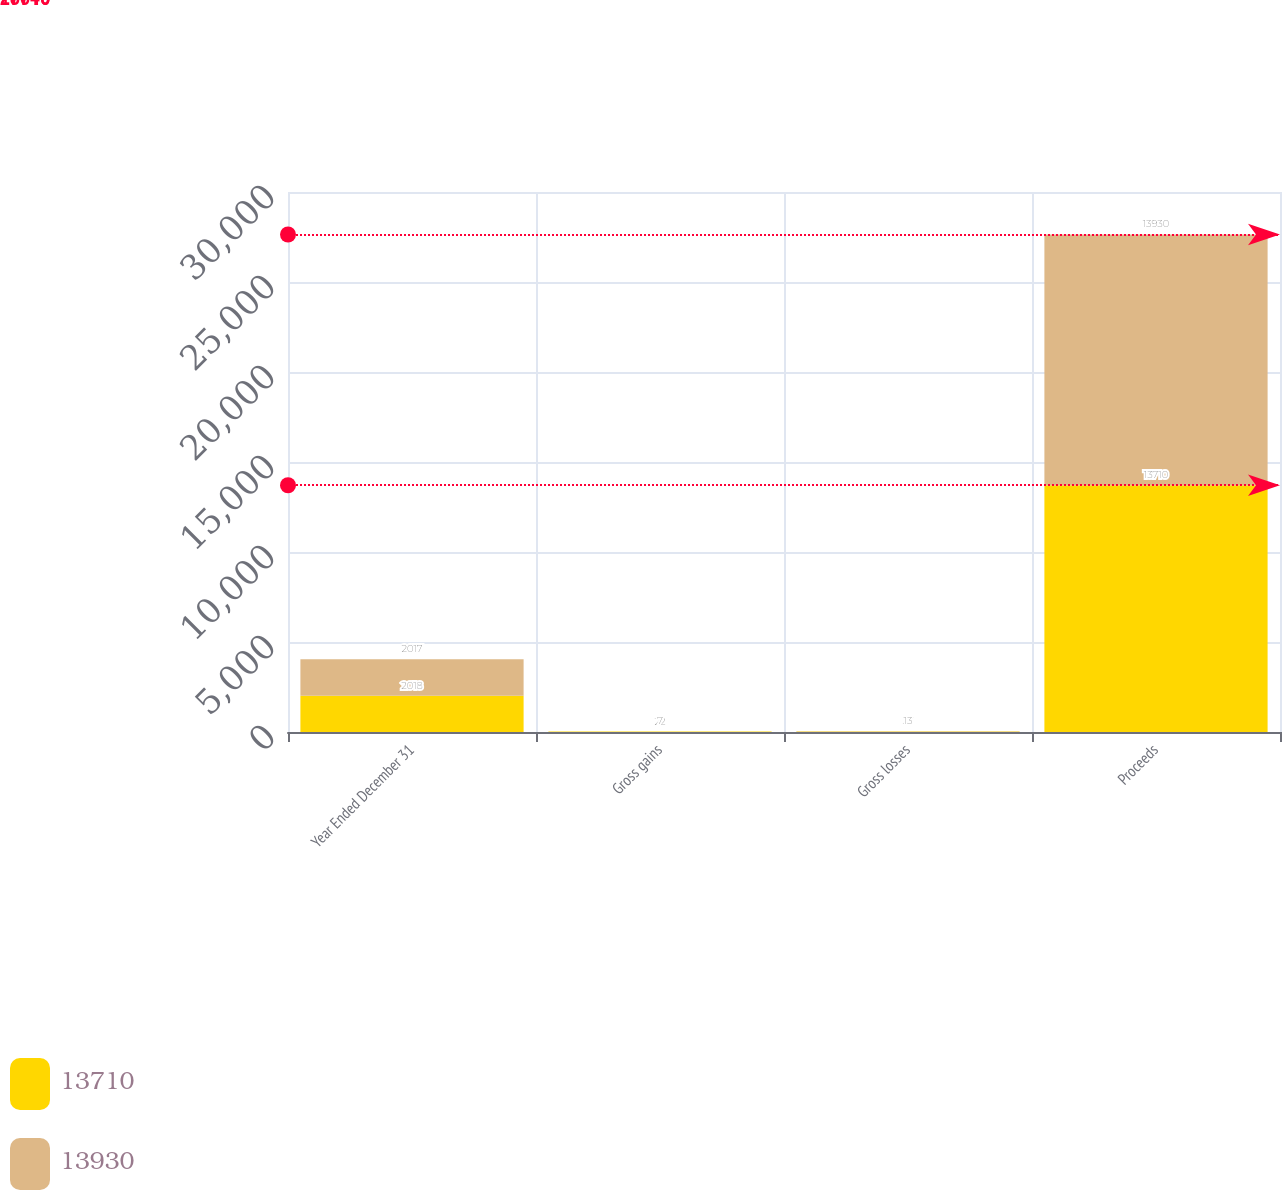Convert chart to OTSL. <chart><loc_0><loc_0><loc_500><loc_500><stacked_bar_chart><ecel><fcel>Year Ended December 31<fcel>Gross gains<fcel>Gross losses<fcel>Proceeds<nl><fcel>13710<fcel>2018<fcel>22<fcel>27<fcel>13710<nl><fcel>13930<fcel>2017<fcel>7<fcel>13<fcel>13930<nl></chart> 